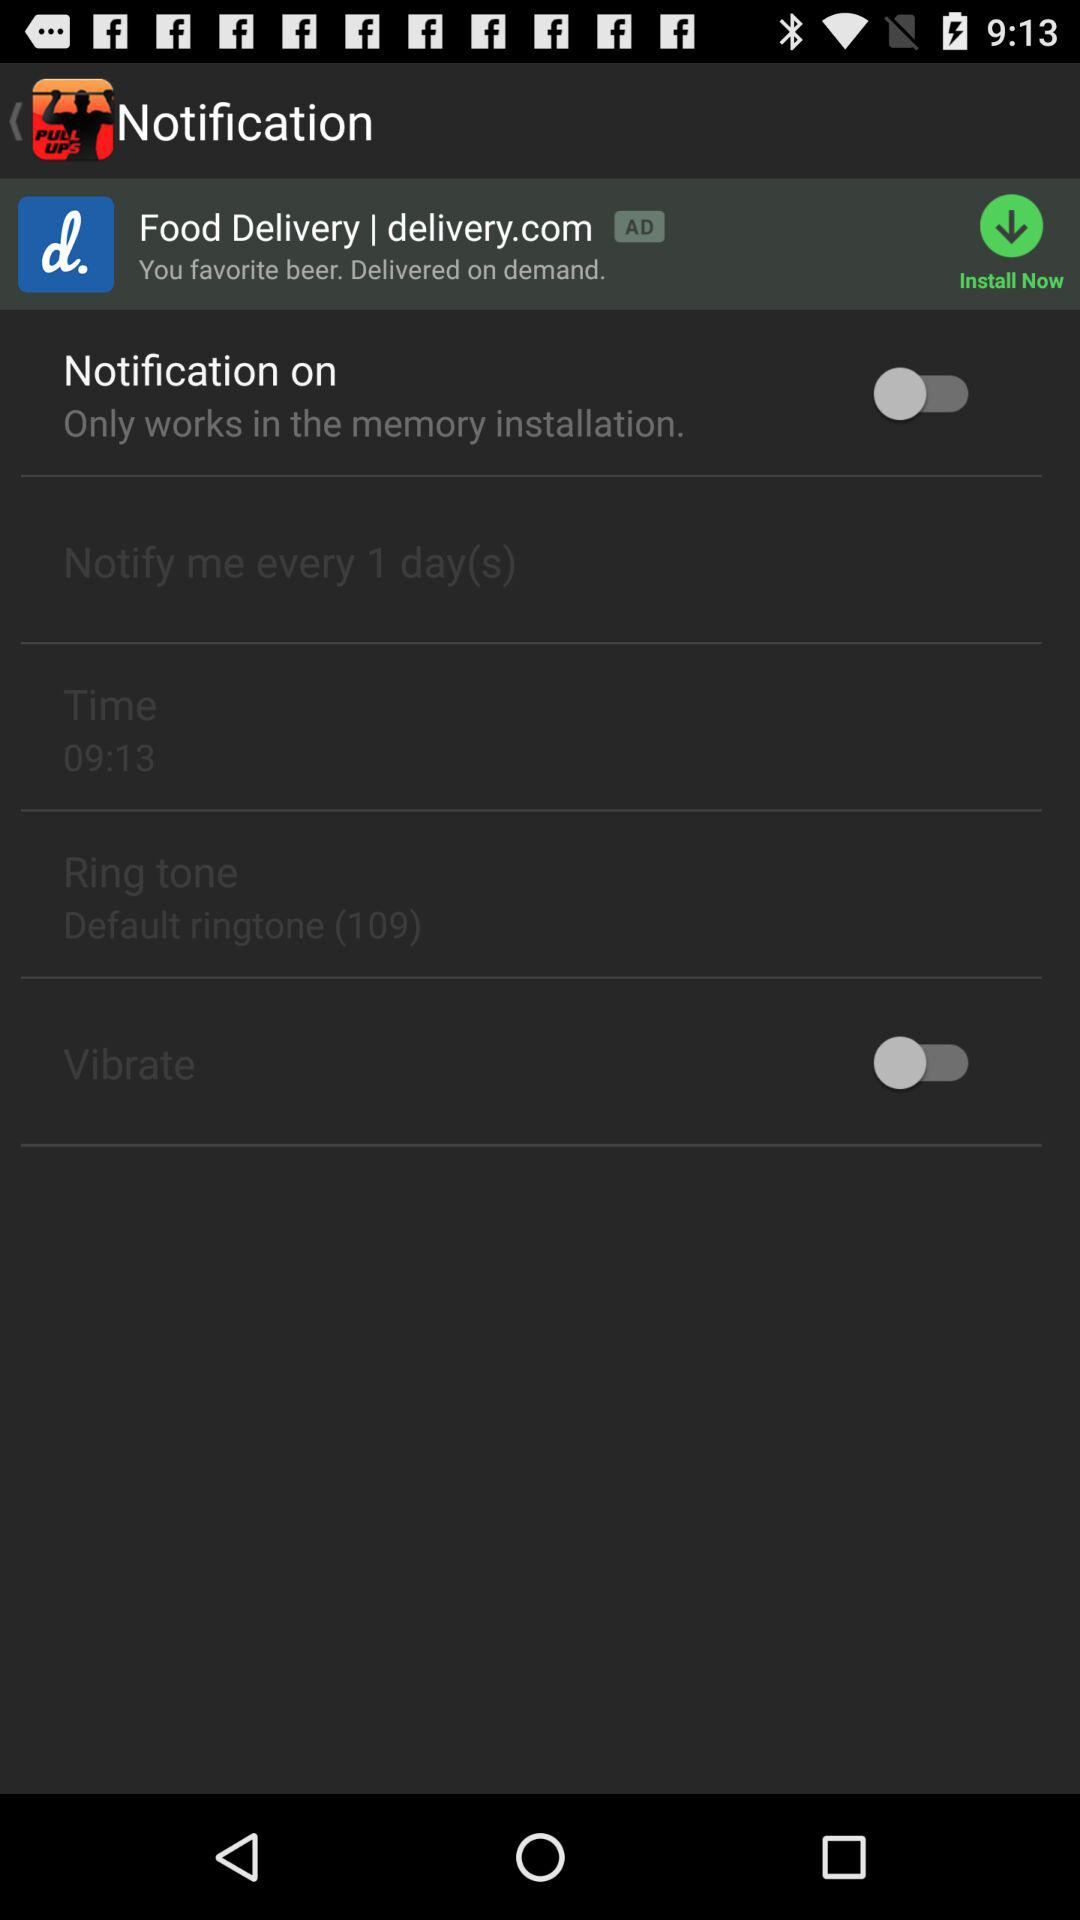What is the status of "Vibrate"? The status is "off". 